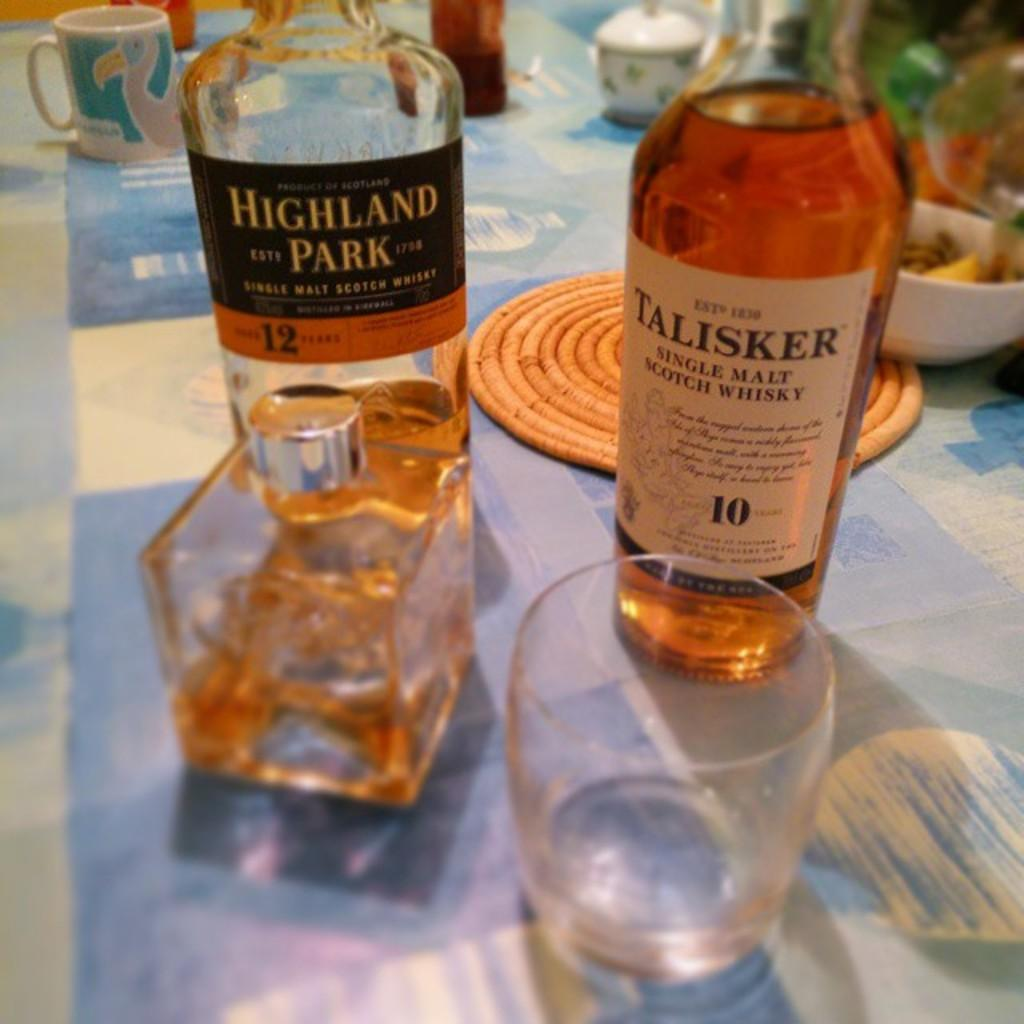<image>
Give a short and clear explanation of the subsequent image. bottles of Highland Park and Talisker are on a table 